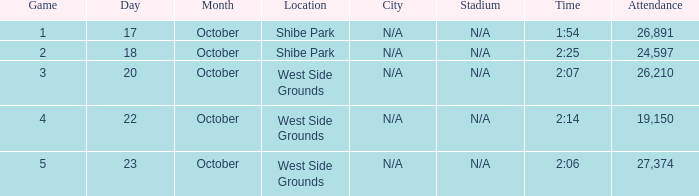For the game that was played on october 22 in west side grounds, what is the total attendance 1.0. 